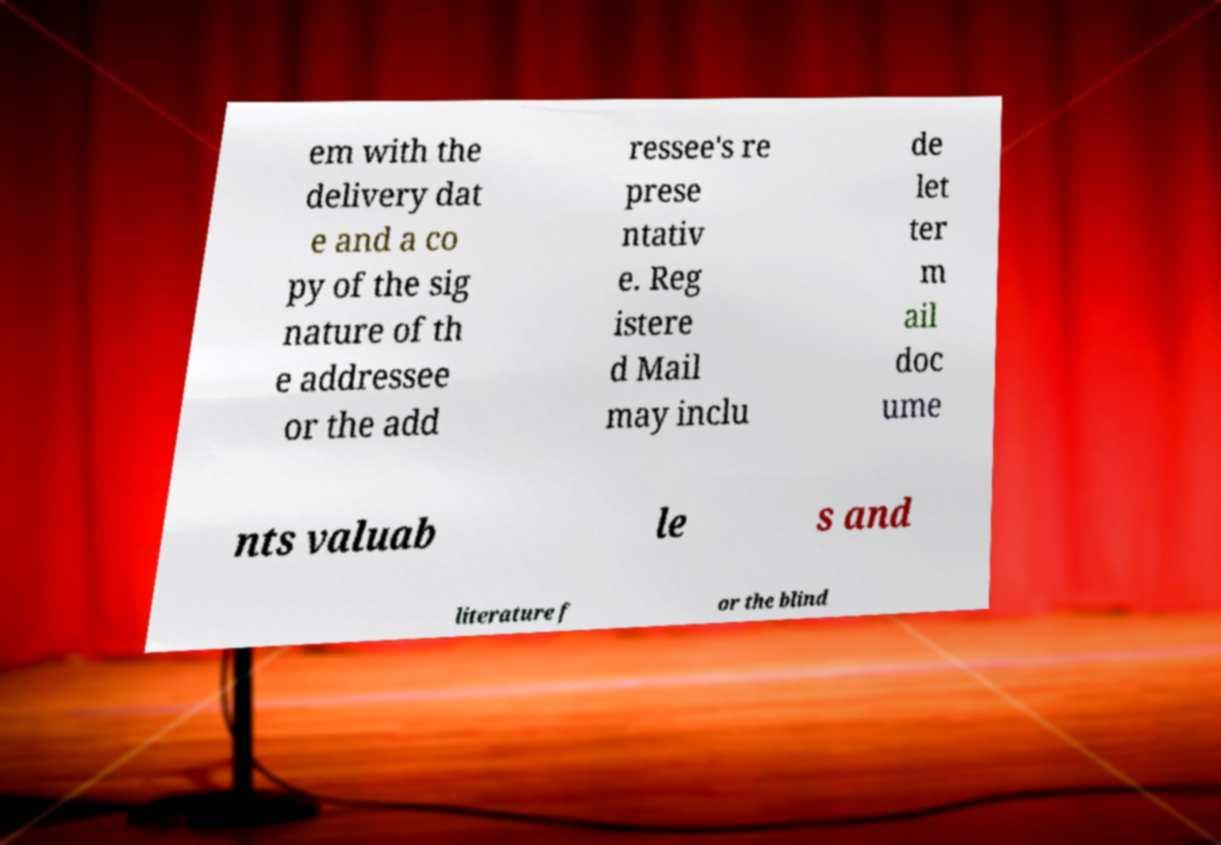Please read and relay the text visible in this image. What does it say? em with the delivery dat e and a co py of the sig nature of th e addressee or the add ressee's re prese ntativ e. Reg istere d Mail may inclu de let ter m ail doc ume nts valuab le s and literature f or the blind 